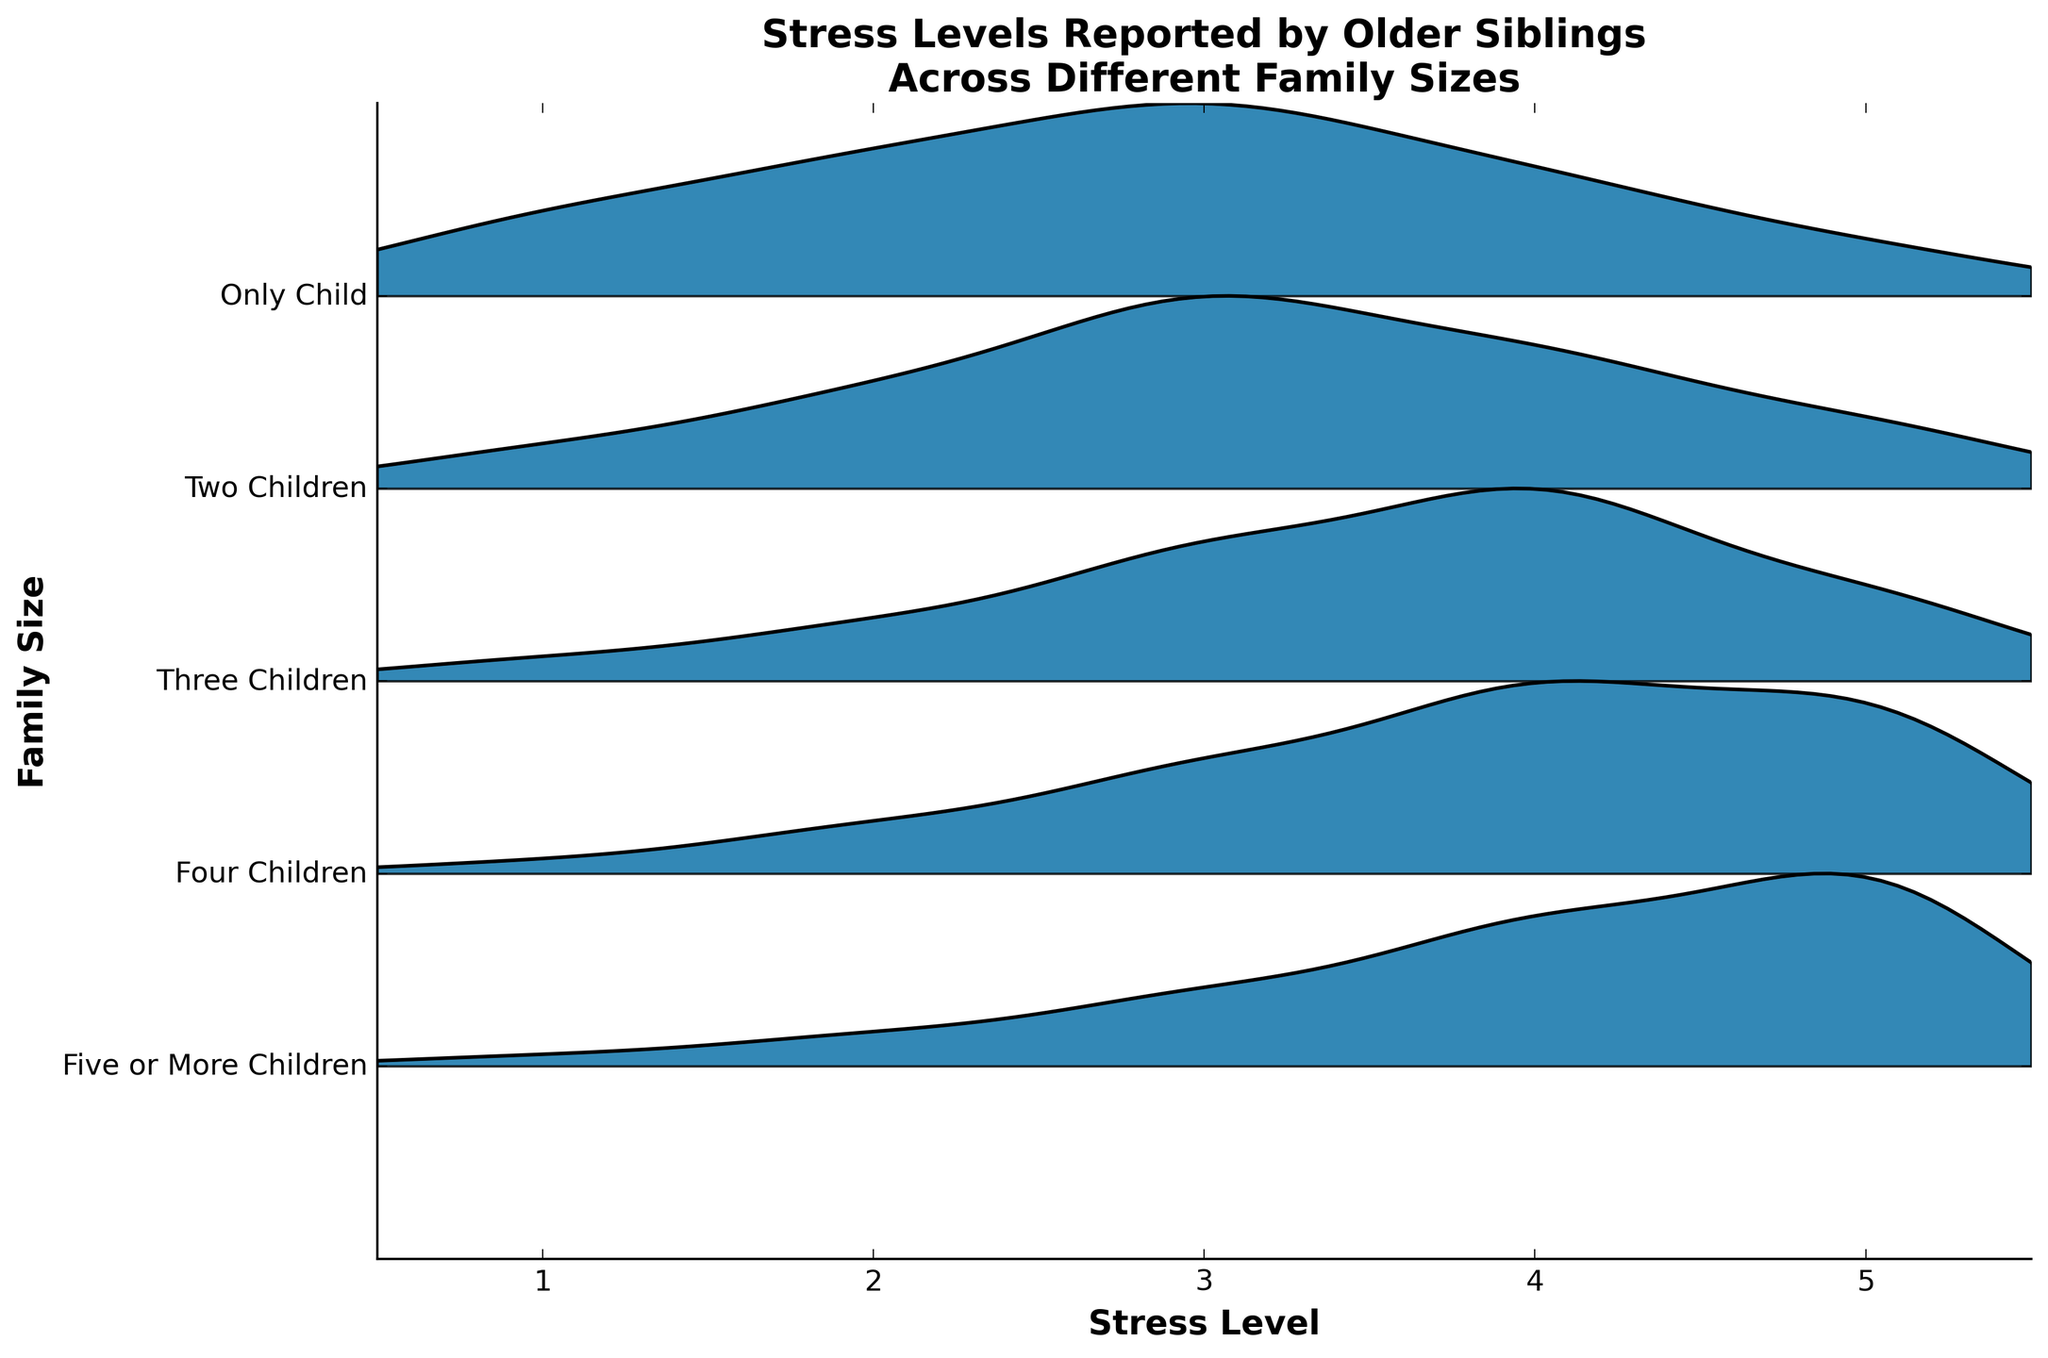what is the title of the plot? The title of the plot is located at the top, serving as a summary of the visualized data. By reading it, we gather that the plot illustrates stress levels reported by older siblings across different family sizes.
Answer: Stress Levels Reported by Older Siblings Across Different Family Sizes What are the axes labeled? The axes labels are found next to each axis. The x-axis is labeled "Stress Level" and the y-axis is labeled "Family Size," indicating what each axis represents.
Answer: "Stress Level" (x-axis) and "Family Size" (y-axis) For which family size is the highest stress level most frequent? The frequency of stress levels can be interpreted from the height of the ridgeline plot. The family size with the highest peak at the highest stress level (5) represents the group with the most frequent highest stress level.
Answer: Five or More Children Which family size shows the widest spread of stress levels? A wider spread of stress levels on the ridgeline plot indicates greater variability. The family size whose plot spans the most along the x-axis represents this.
Answer: Five or More Children How many family sizes are compared in the plot? Counting the discrete categories on the y-axis will reveal how many family sizes are included in the comparison.
Answer: Five family sizes Which family size has the smallest peak at stress level 1? By comparing the peaks at stress level 1 for each family size, the family with the smallest peak indicates the lowest frequency at this stress level.
Answer: Four Children What is the general trend in stress levels as family size increases? Analyzing the peaks and spreads of the ridgeline plots for each increasing family size can help identify the trend. One needs to observe whether higher stress frequencies shift rightwards (towards higher stress levels) as family size increases.
Answer: Stress levels tend to increase as family size increases How do the stress levels for 'Only Child' compare with 'Three Children'? Comparing the ridgeline plots for "Only Child" and "Three Children," we observe their respective stress level distributions. Higher peaks at certain stress levels indicate more frequent reports of those stress levels.
Answer: Three Children report higher stress levels more frequently than Only Child At what stress level does the 'Two Children' family size reach its peak frequency? Identifying the tallest peak in the "Two Children" ridgeline plot will determine at which stress level it reaches its peak frequency.
Answer: Stress Level 3 Which family size appears to handle stress better with less variety in stress levels? A family size with a concentrated (narrow) ridgeline plot suggests less variety and possibly better handling of stress. Observing for the most concentrated plot helps us identify this.
Answer: Two Children 